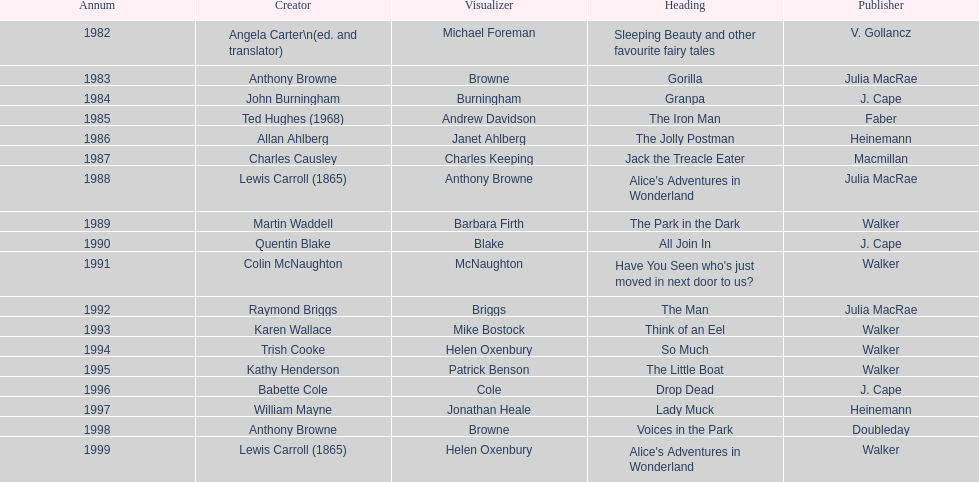Which other author, besides lewis carroll, has won the kurt maschler award twice? Anthony Browne. 